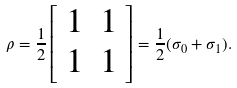Convert formula to latex. <formula><loc_0><loc_0><loc_500><loc_500>\rho = \frac { 1 } { 2 } \left [ \begin{array} { c c } 1 & 1 \\ 1 & 1 \end{array} \right ] = \frac { 1 } { 2 } ( \sigma _ { 0 } + \sigma _ { 1 } ) .</formula> 